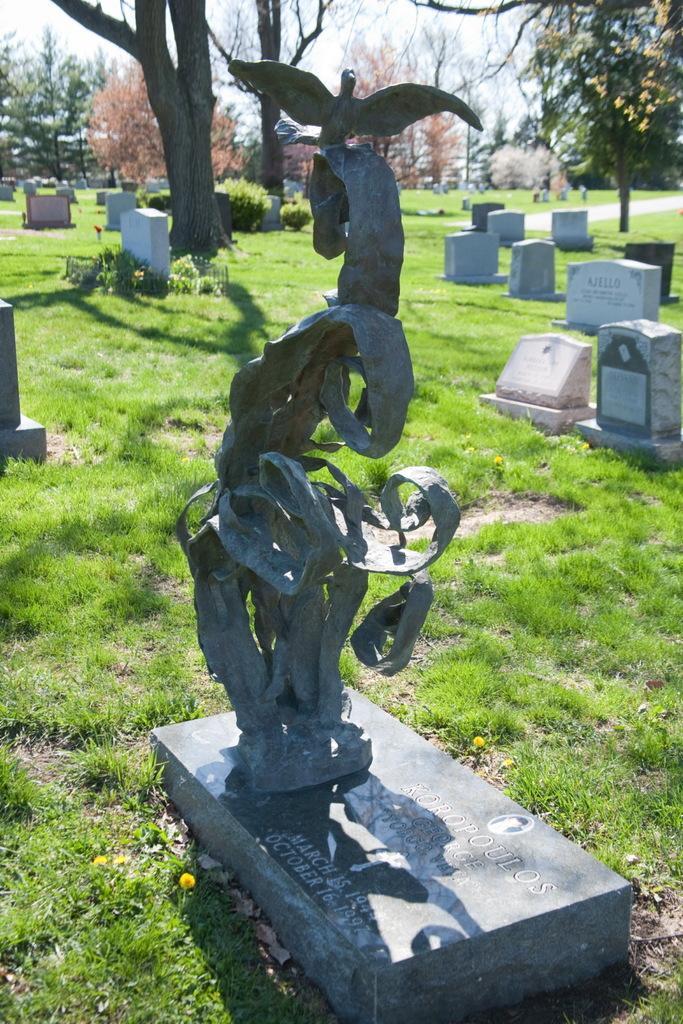In one or two sentences, can you explain what this image depicts? To the front middle of the image there is a cemetery with a statue on it. In the background on the grass there is a cemetery and also there are many trees. 